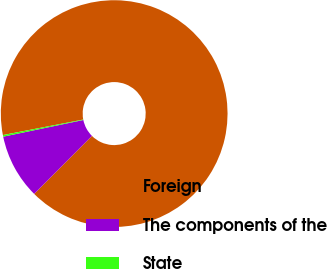Convert chart to OTSL. <chart><loc_0><loc_0><loc_500><loc_500><pie_chart><fcel>Foreign<fcel>The components of the<fcel>State<nl><fcel>90.51%<fcel>9.26%<fcel>0.23%<nl></chart> 